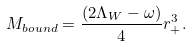<formula> <loc_0><loc_0><loc_500><loc_500>M _ { b o u n d } = \frac { ( 2 \Lambda _ { W } - \omega ) } { 4 } r _ { + } ^ { 3 } .</formula> 